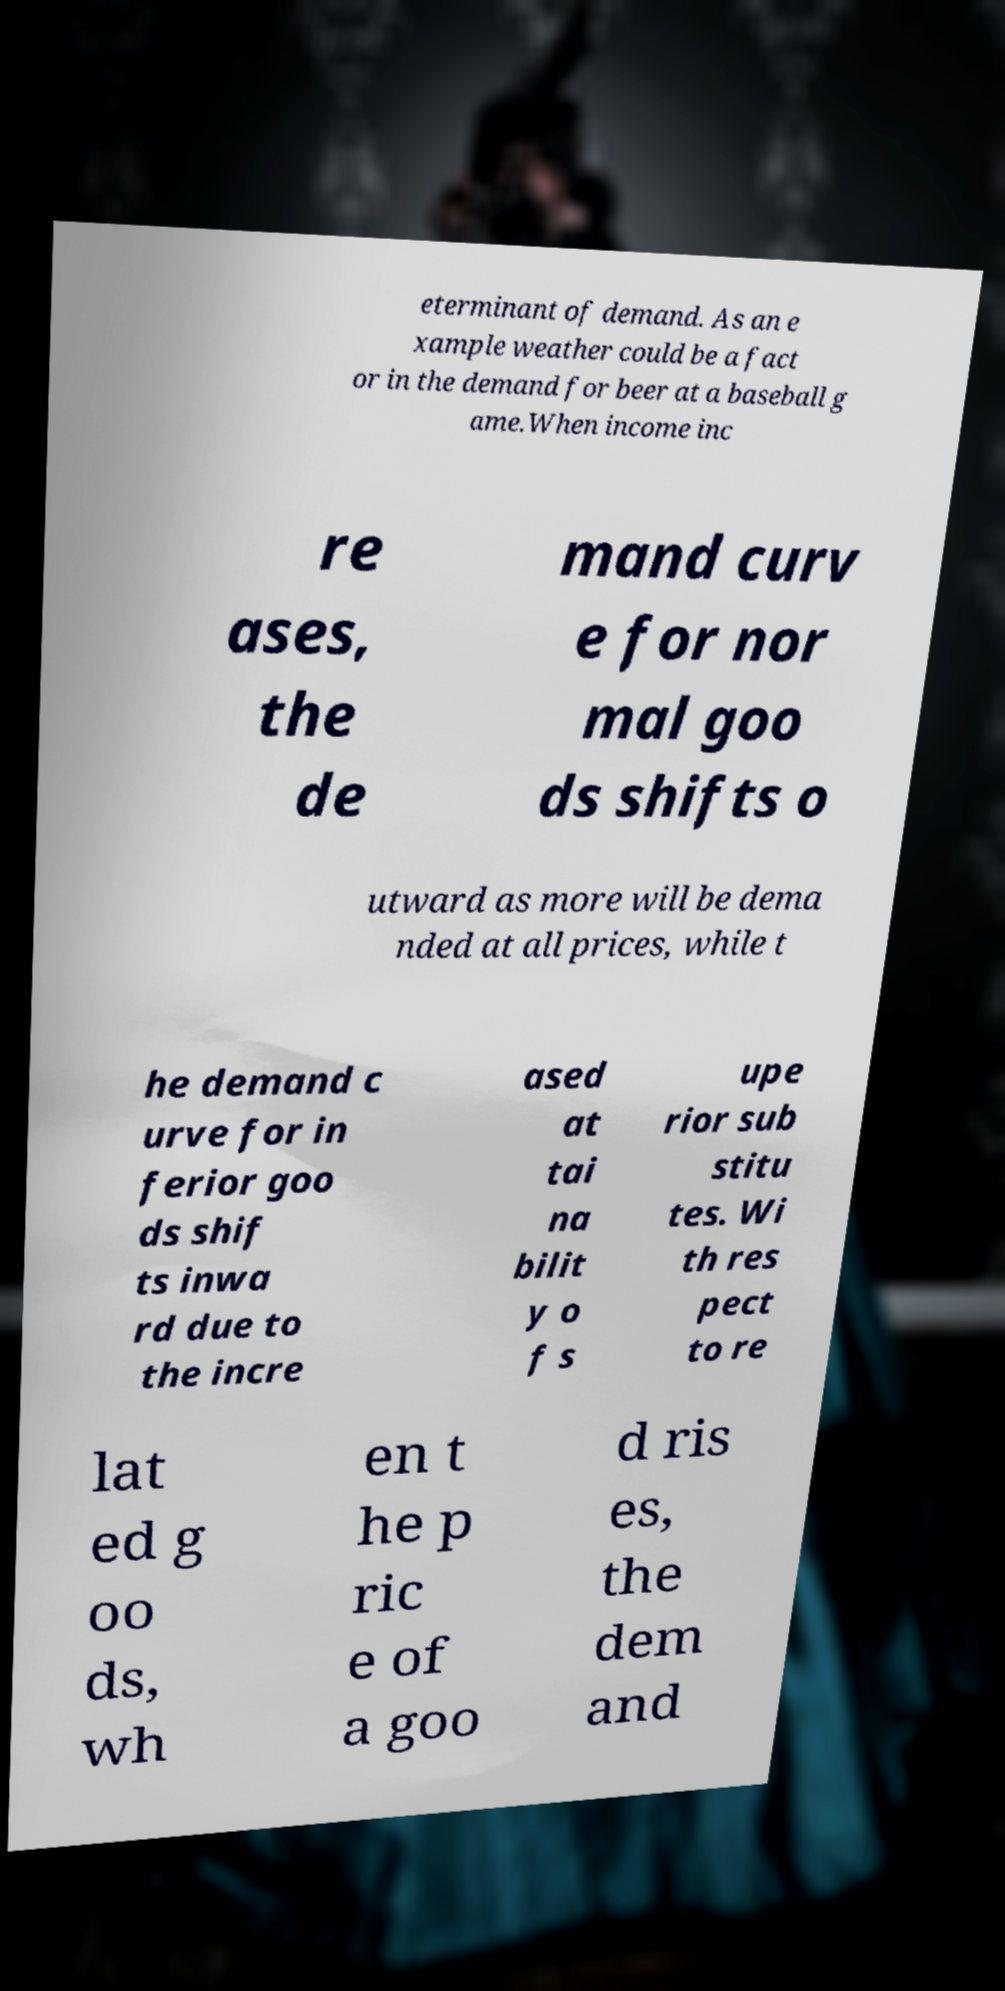What messages or text are displayed in this image? I need them in a readable, typed format. eterminant of demand. As an e xample weather could be a fact or in the demand for beer at a baseball g ame.When income inc re ases, the de mand curv e for nor mal goo ds shifts o utward as more will be dema nded at all prices, while t he demand c urve for in ferior goo ds shif ts inwa rd due to the incre ased at tai na bilit y o f s upe rior sub stitu tes. Wi th res pect to re lat ed g oo ds, wh en t he p ric e of a goo d ris es, the dem and 